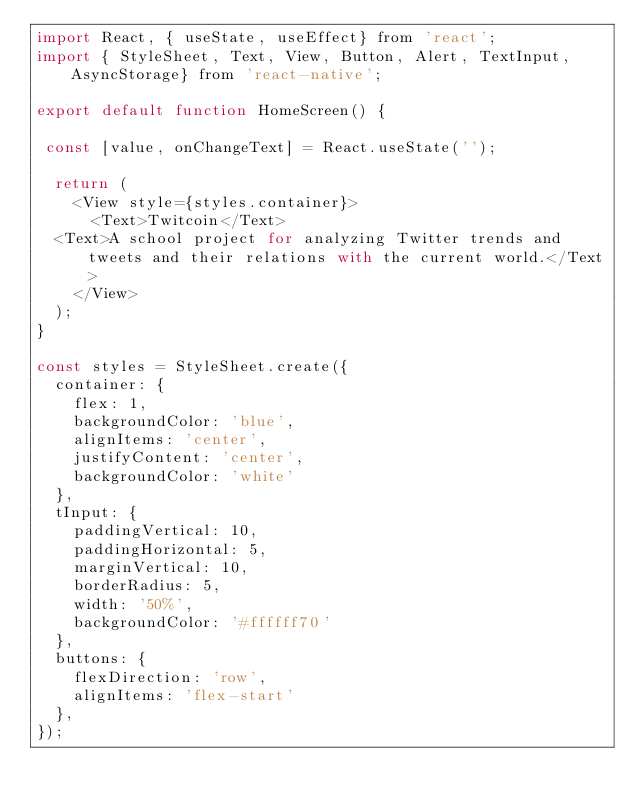<code> <loc_0><loc_0><loc_500><loc_500><_JavaScript_>import React, { useState, useEffect} from 'react';
import { StyleSheet, Text, View, Button, Alert, TextInput, AsyncStorage} from 'react-native';

export default function HomeScreen() {

 const [value, onChangeText] = React.useState('');

  return (
    <View style={styles.container}>
      <Text>Twitcoin</Text>
  <Text>A school project for analyzing Twitter trends and tweets and their relations with the current world.</Text>
    </View>
  );
}

const styles = StyleSheet.create({
  container: {
    flex: 1,
    backgroundColor: 'blue',
    alignItems: 'center',
    justifyContent: 'center',
    backgroundColor: 'white'
  },
  tInput: {
    paddingVertical: 10,
    paddingHorizontal: 5,
    marginVertical: 10,
    borderRadius: 5,
    width: '50%',
    backgroundColor: '#ffffff70'
  },
  buttons: {
    flexDirection: 'row',
    alignItems: 'flex-start'
  },
});
</code> 